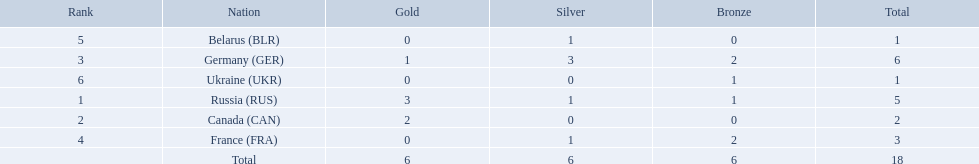What are all the countries in the 1994 winter olympics biathlon? Russia (RUS), Canada (CAN), Germany (GER), France (FRA), Belarus (BLR), Ukraine (UKR). Which of these received at least one gold medal? Russia (RUS), Canada (CAN), Germany (GER). Which of these received no silver or bronze medals? Canada (CAN). 